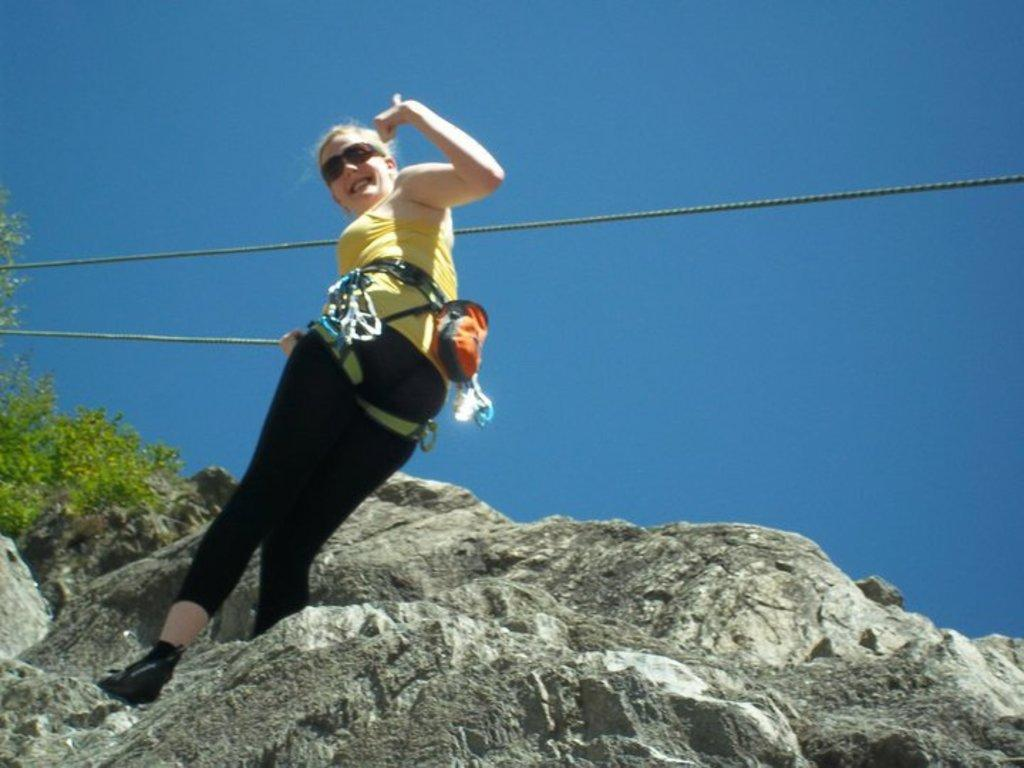Who is present in the image? There is a woman in the image. Where is the woman located in the image? The woman is standing in the middle of the image. What is the woman holding in the image? The woman is holding a rope. What is the woman's facial expression in the image? The woman is smiling. What can be seen behind the woman in the image? There is a hill and trees behind the woman. What is visible at the top of the image? The sky is visible at the top of the image. How many snakes are slithering around the woman's feet in the image? There are no snakes present in the image. Can you compare the woman's smile to the smile of a famous celebrity in the image? There is no comparison to a famous celebrity's smile in the image, as only the woman's smile is visible. 